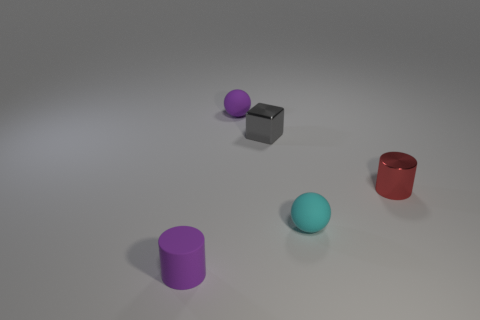There is a small cylinder that is on the right side of the rubber cylinder; what is its color?
Make the answer very short. Red. Is the material of the red cylinder the same as the small cylinder that is on the left side of the block?
Your answer should be very brief. No. What is the material of the red cylinder?
Offer a terse response. Metal. There is a small object that is the same material as the small cube; what shape is it?
Make the answer very short. Cylinder. What number of other things are there of the same shape as the gray thing?
Your answer should be very brief. 0. How many purple spheres are in front of the purple cylinder?
Offer a very short reply. 0. Does the cylinder that is left of the tiny red cylinder have the same size as the ball that is to the left of the cyan ball?
Your response must be concise. Yes. How many other things are the same size as the rubber cylinder?
Your answer should be compact. 4. What is the material of the small cylinder that is behind the tiny cylinder that is to the left of the tiny purple sphere behind the red object?
Your answer should be very brief. Metal. Is the size of the purple ball the same as the sphere that is in front of the red shiny object?
Your response must be concise. Yes. 